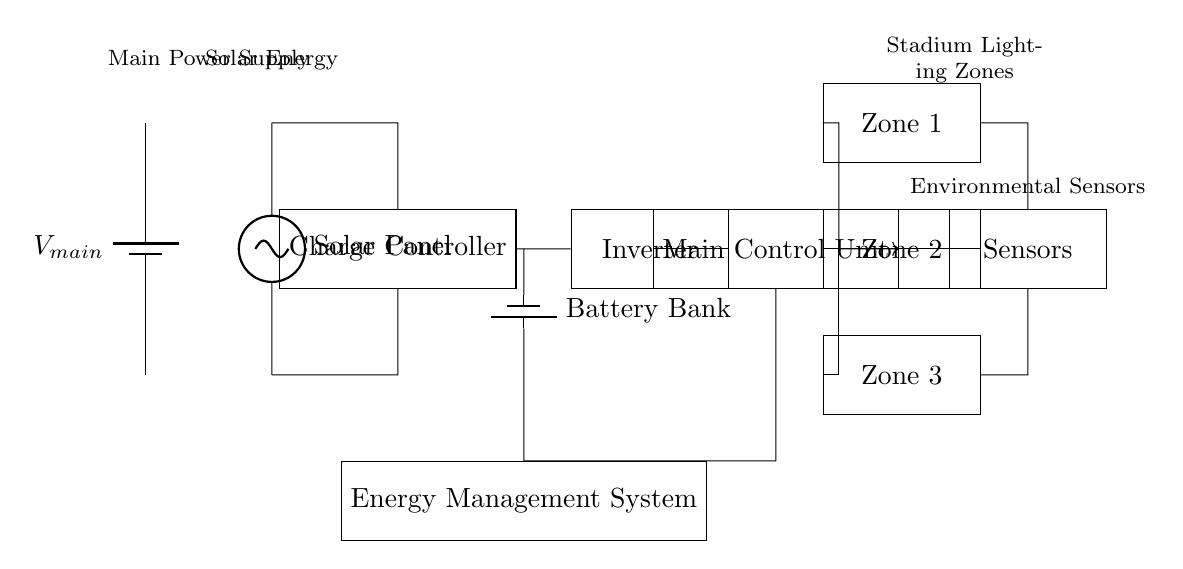What is the main power supply in the circuit? The main power supply is indicated by the symbol for a battery, labeled as V main in the diagram.
Answer: V main How many zones of lighting are represented in this circuit? There are three lighting zones labeled as Zone 1, Zone 2, and Zone 3, indicated by their respective rectangles in the diagram.
Answer: 3 What component converts DC power to AC power in this circuit? The inverter, labeled as Inverter in the diagram, is responsible for converting direct current (DC) to alternating current (AC).
Answer: Inverter What is the role of the charge controller in this circuit? The charge controller regulates the voltage and current coming from the solar panel to prevent overcharging and manage battery levels.
Answer: Regulate charging Which component receives feedback from the sensors? The main control unit, labeled as Main Control Unit, receives feedback from the environmental sensors, which are connected via arrows in the diagram.
Answer: Main Control Unit How is solar energy incorporated into this circuit? Solar energy is captured through the solar panel, represented by a voltage source symbol in the diagram, which connects to the charge controller.
Answer: Solar Panel What provides power to the stadium lighting zones? The energy management system supplies power to the lighting zones, ensuring efficient energy usage and distribution within the stadium's lighting circuitry.
Answer: Energy Management System 